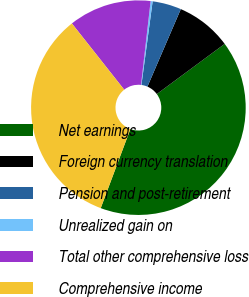<chart> <loc_0><loc_0><loc_500><loc_500><pie_chart><fcel>Net earnings<fcel>Foreign currency translation<fcel>Pension and post-retirement<fcel>Unrealized gain on<fcel>Total other comprehensive loss<fcel>Comprehensive income<nl><fcel>40.84%<fcel>8.4%<fcel>4.35%<fcel>0.3%<fcel>12.46%<fcel>33.65%<nl></chart> 